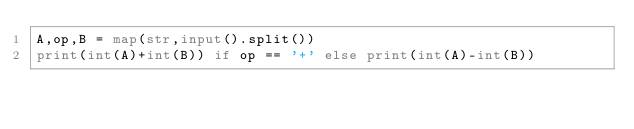Convert code to text. <code><loc_0><loc_0><loc_500><loc_500><_Python_>A,op,B = map(str,input().split())
print(int(A)+int(B)) if op == '+' else print(int(A)-int(B))</code> 